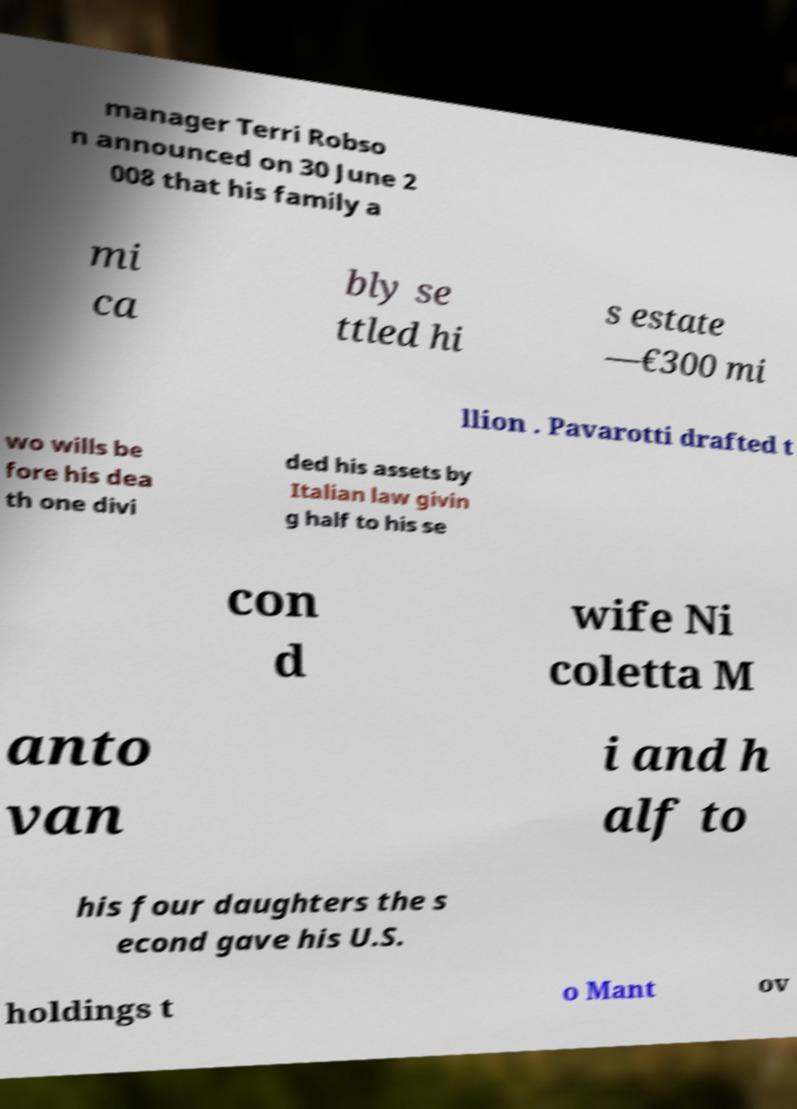Could you assist in decoding the text presented in this image and type it out clearly? manager Terri Robso n announced on 30 June 2 008 that his family a mi ca bly se ttled hi s estate —€300 mi llion . Pavarotti drafted t wo wills be fore his dea th one divi ded his assets by Italian law givin g half to his se con d wife Ni coletta M anto van i and h alf to his four daughters the s econd gave his U.S. holdings t o Mant ov 